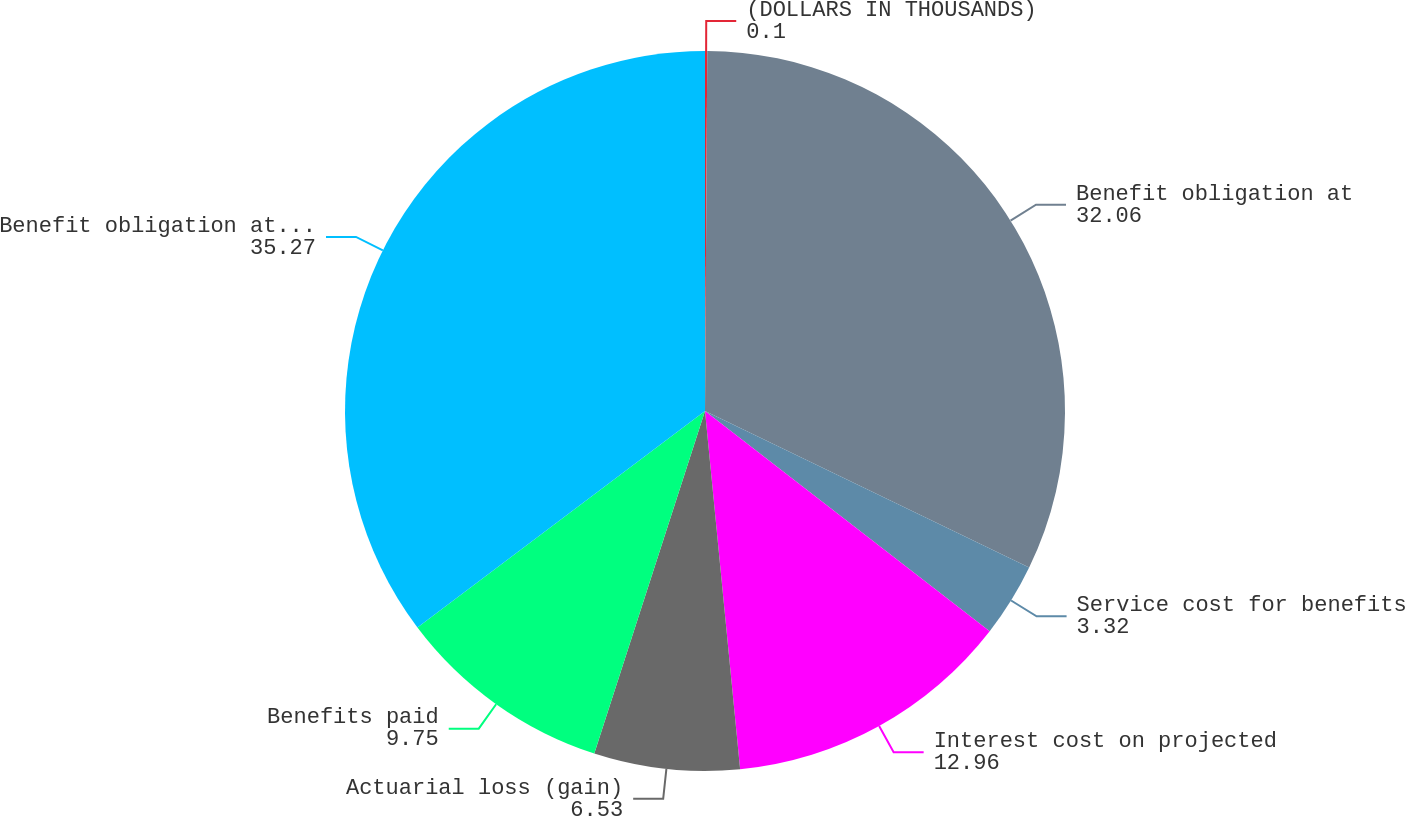<chart> <loc_0><loc_0><loc_500><loc_500><pie_chart><fcel>(DOLLARS IN THOUSANDS)<fcel>Benefit obligation at<fcel>Service cost for benefits<fcel>Interest cost on projected<fcel>Actuarial loss (gain)<fcel>Benefits paid<fcel>Benefit obligation at end of<nl><fcel>0.1%<fcel>32.06%<fcel>3.32%<fcel>12.96%<fcel>6.53%<fcel>9.75%<fcel>35.27%<nl></chart> 